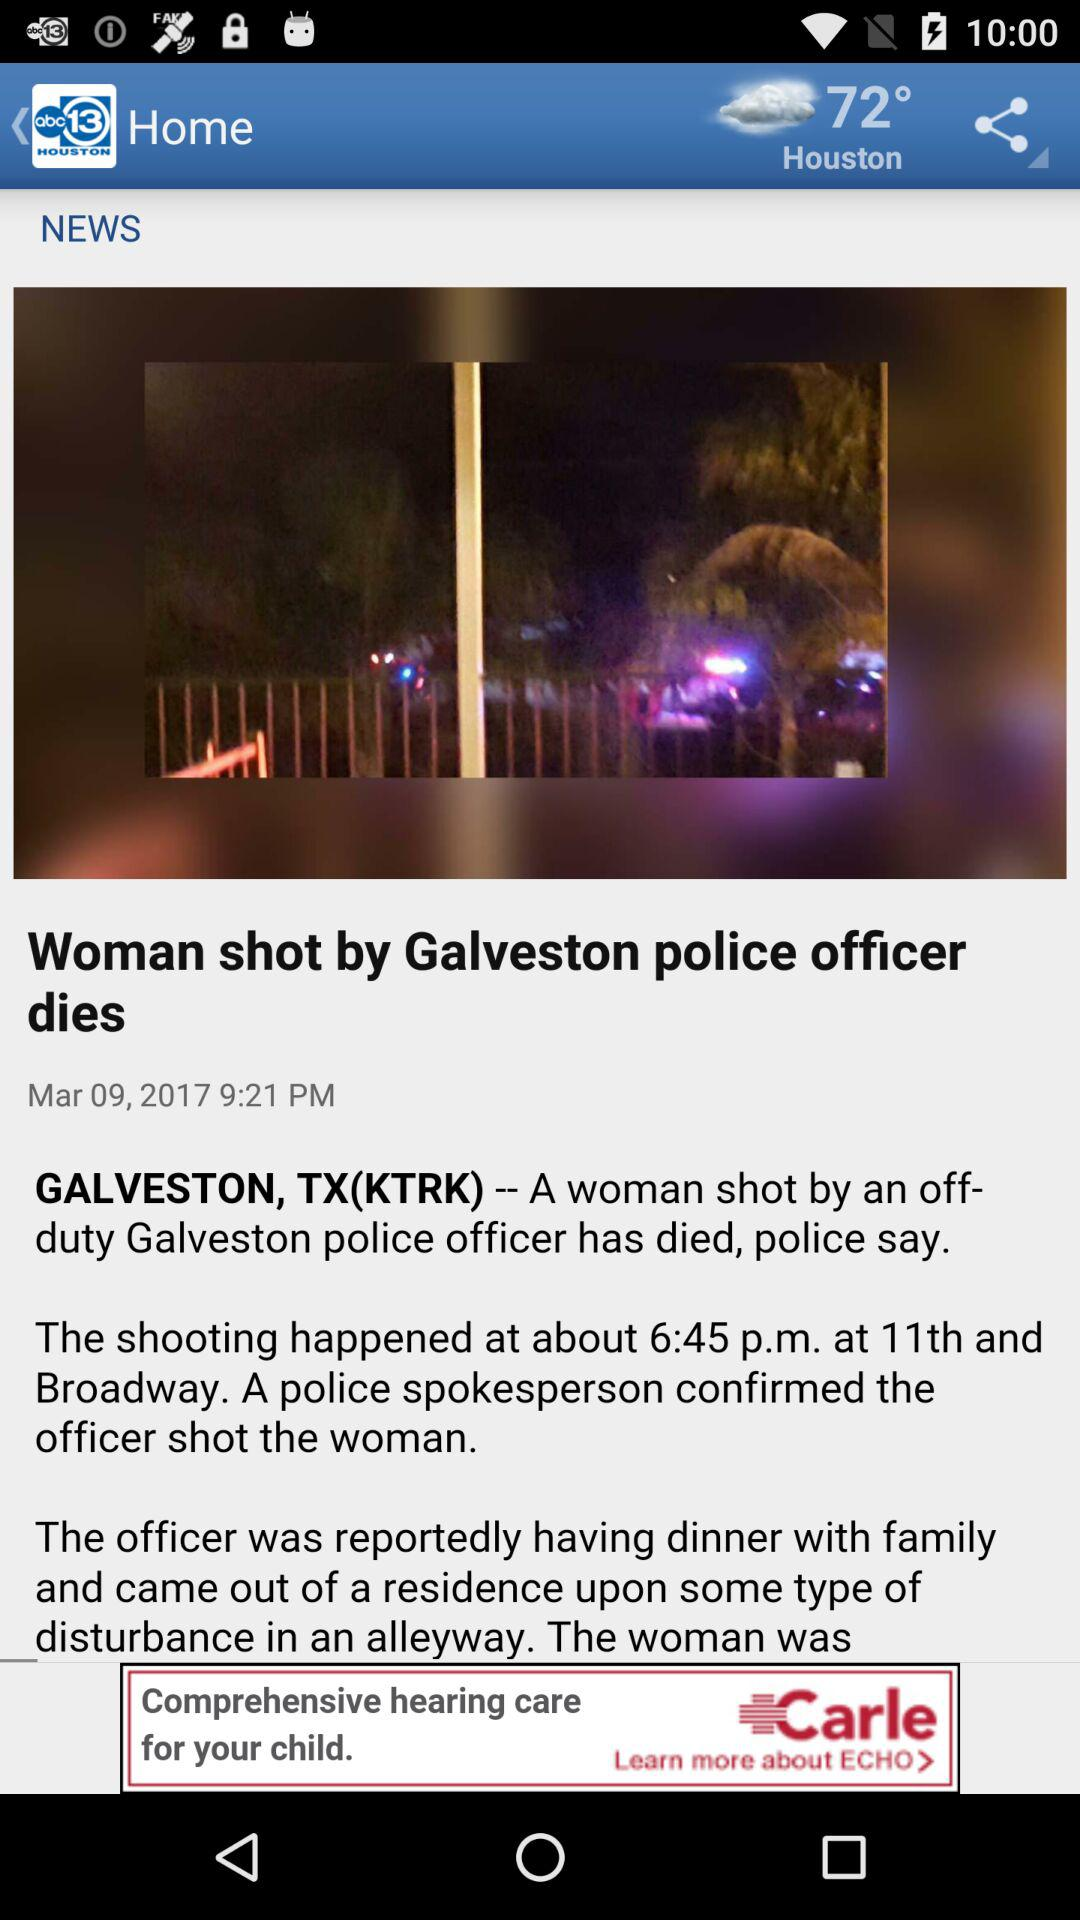What is the temperature? The temperature is 72°. 